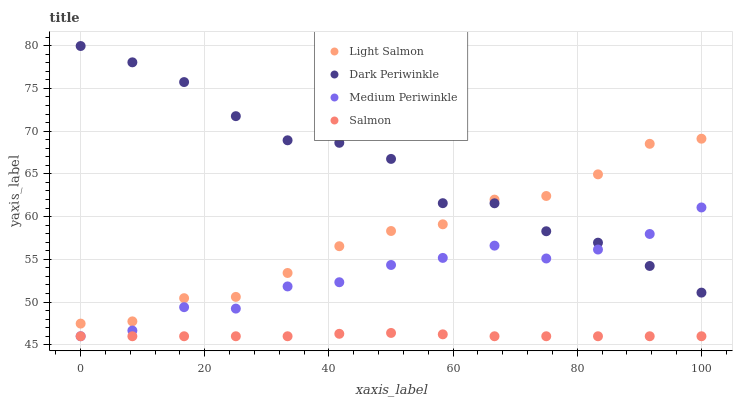Does Salmon have the minimum area under the curve?
Answer yes or no. Yes. Does Dark Periwinkle have the maximum area under the curve?
Answer yes or no. Yes. Does Light Salmon have the minimum area under the curve?
Answer yes or no. No. Does Light Salmon have the maximum area under the curve?
Answer yes or no. No. Is Salmon the smoothest?
Answer yes or no. Yes. Is Dark Periwinkle the roughest?
Answer yes or no. Yes. Is Light Salmon the smoothest?
Answer yes or no. No. Is Light Salmon the roughest?
Answer yes or no. No. Does Salmon have the lowest value?
Answer yes or no. Yes. Does Light Salmon have the lowest value?
Answer yes or no. No. Does Dark Periwinkle have the highest value?
Answer yes or no. Yes. Does Light Salmon have the highest value?
Answer yes or no. No. Is Salmon less than Light Salmon?
Answer yes or no. Yes. Is Dark Periwinkle greater than Salmon?
Answer yes or no. Yes. Does Medium Periwinkle intersect Salmon?
Answer yes or no. Yes. Is Medium Periwinkle less than Salmon?
Answer yes or no. No. Is Medium Periwinkle greater than Salmon?
Answer yes or no. No. Does Salmon intersect Light Salmon?
Answer yes or no. No. 